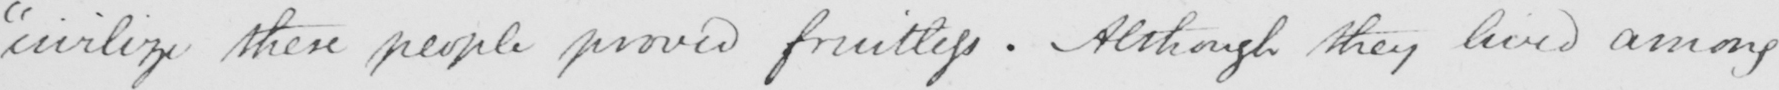Please provide the text content of this handwritten line. "civilize these people proved fruitless. Although they lived among 